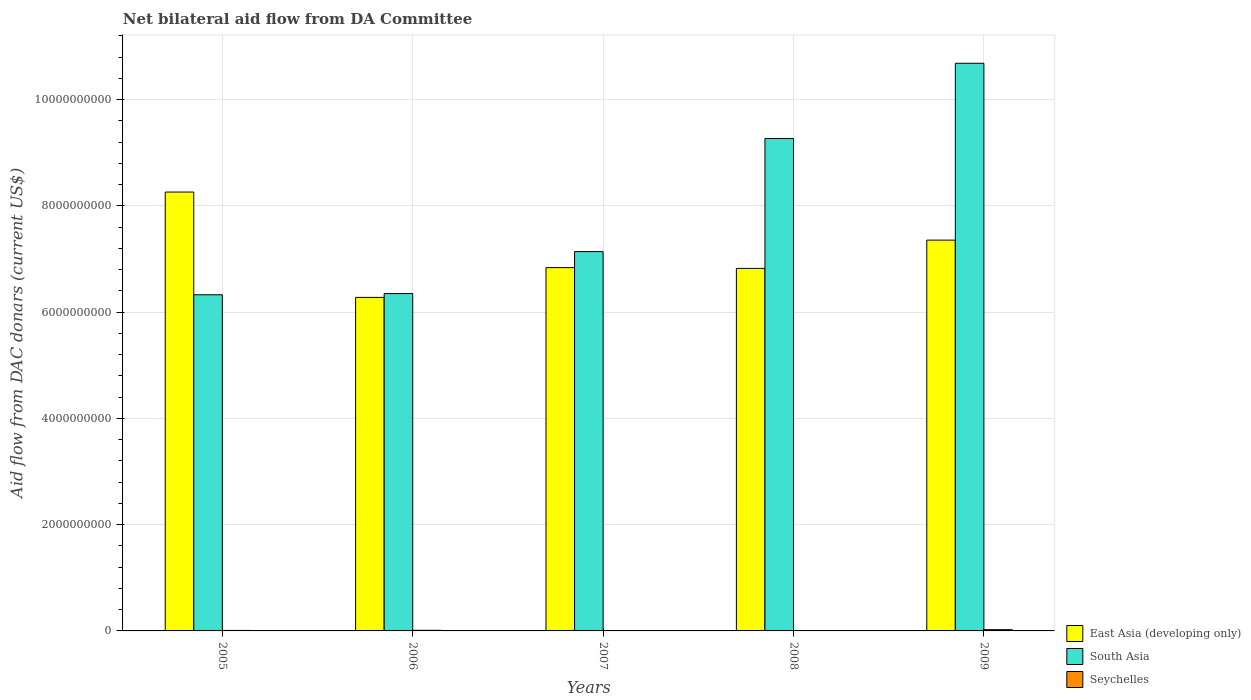How many bars are there on the 5th tick from the left?
Provide a succinct answer. 3. What is the aid flow in in South Asia in 2007?
Ensure brevity in your answer.  7.14e+09. Across all years, what is the maximum aid flow in in South Asia?
Ensure brevity in your answer.  1.07e+1. Across all years, what is the minimum aid flow in in Seychelles?
Your answer should be very brief. 2.29e+06. In which year was the aid flow in in Seychelles maximum?
Offer a very short reply. 2009. In which year was the aid flow in in Seychelles minimum?
Offer a very short reply. 2007. What is the total aid flow in in Seychelles in the graph?
Ensure brevity in your answer.  5.27e+07. What is the difference between the aid flow in in South Asia in 2006 and that in 2008?
Give a very brief answer. -2.92e+09. What is the difference between the aid flow in in Seychelles in 2008 and the aid flow in in South Asia in 2006?
Make the answer very short. -6.34e+09. What is the average aid flow in in South Asia per year?
Offer a very short reply. 7.95e+09. In the year 2009, what is the difference between the aid flow in in South Asia and aid flow in in East Asia (developing only)?
Provide a short and direct response. 3.33e+09. What is the ratio of the aid flow in in East Asia (developing only) in 2008 to that in 2009?
Offer a very short reply. 0.93. Is the aid flow in in East Asia (developing only) in 2008 less than that in 2009?
Your answer should be compact. Yes. Is the difference between the aid flow in in South Asia in 2005 and 2007 greater than the difference between the aid flow in in East Asia (developing only) in 2005 and 2007?
Your answer should be compact. No. What is the difference between the highest and the second highest aid flow in in South Asia?
Offer a terse response. 1.42e+09. What is the difference between the highest and the lowest aid flow in in East Asia (developing only)?
Ensure brevity in your answer.  1.98e+09. In how many years, is the aid flow in in East Asia (developing only) greater than the average aid flow in in East Asia (developing only) taken over all years?
Your answer should be very brief. 2. What does the 1st bar from the left in 2005 represents?
Keep it short and to the point. East Asia (developing only). What does the 3rd bar from the right in 2008 represents?
Ensure brevity in your answer.  East Asia (developing only). Is it the case that in every year, the sum of the aid flow in in South Asia and aid flow in in East Asia (developing only) is greater than the aid flow in in Seychelles?
Your answer should be compact. Yes. Are all the bars in the graph horizontal?
Your response must be concise. No. Are the values on the major ticks of Y-axis written in scientific E-notation?
Offer a very short reply. No. How are the legend labels stacked?
Your answer should be compact. Vertical. What is the title of the graph?
Your response must be concise. Net bilateral aid flow from DA Committee. Does "Sudan" appear as one of the legend labels in the graph?
Make the answer very short. No. What is the label or title of the Y-axis?
Your answer should be compact. Aid flow from DAC donars (current US$). What is the Aid flow from DAC donars (current US$) of East Asia (developing only) in 2005?
Give a very brief answer. 8.26e+09. What is the Aid flow from DAC donars (current US$) in South Asia in 2005?
Provide a short and direct response. 6.33e+09. What is the Aid flow from DAC donars (current US$) in Seychelles in 2005?
Provide a short and direct response. 9.34e+06. What is the Aid flow from DAC donars (current US$) in East Asia (developing only) in 2006?
Your answer should be very brief. 6.28e+09. What is the Aid flow from DAC donars (current US$) of South Asia in 2006?
Provide a short and direct response. 6.35e+09. What is the Aid flow from DAC donars (current US$) of Seychelles in 2006?
Offer a very short reply. 1.16e+07. What is the Aid flow from DAC donars (current US$) in East Asia (developing only) in 2007?
Offer a terse response. 6.84e+09. What is the Aid flow from DAC donars (current US$) of South Asia in 2007?
Provide a succinct answer. 7.14e+09. What is the Aid flow from DAC donars (current US$) in Seychelles in 2007?
Your response must be concise. 2.29e+06. What is the Aid flow from DAC donars (current US$) in East Asia (developing only) in 2008?
Give a very brief answer. 6.82e+09. What is the Aid flow from DAC donars (current US$) in South Asia in 2008?
Your answer should be very brief. 9.27e+09. What is the Aid flow from DAC donars (current US$) of Seychelles in 2008?
Your answer should be very brief. 5.77e+06. What is the Aid flow from DAC donars (current US$) in East Asia (developing only) in 2009?
Your answer should be very brief. 7.35e+09. What is the Aid flow from DAC donars (current US$) of South Asia in 2009?
Provide a succinct answer. 1.07e+1. What is the Aid flow from DAC donars (current US$) of Seychelles in 2009?
Provide a succinct answer. 2.38e+07. Across all years, what is the maximum Aid flow from DAC donars (current US$) of East Asia (developing only)?
Offer a terse response. 8.26e+09. Across all years, what is the maximum Aid flow from DAC donars (current US$) in South Asia?
Provide a short and direct response. 1.07e+1. Across all years, what is the maximum Aid flow from DAC donars (current US$) in Seychelles?
Provide a succinct answer. 2.38e+07. Across all years, what is the minimum Aid flow from DAC donars (current US$) in East Asia (developing only)?
Ensure brevity in your answer.  6.28e+09. Across all years, what is the minimum Aid flow from DAC donars (current US$) in South Asia?
Your answer should be compact. 6.33e+09. Across all years, what is the minimum Aid flow from DAC donars (current US$) of Seychelles?
Your answer should be very brief. 2.29e+06. What is the total Aid flow from DAC donars (current US$) of East Asia (developing only) in the graph?
Provide a short and direct response. 3.55e+1. What is the total Aid flow from DAC donars (current US$) in South Asia in the graph?
Make the answer very short. 3.98e+1. What is the total Aid flow from DAC donars (current US$) of Seychelles in the graph?
Ensure brevity in your answer.  5.27e+07. What is the difference between the Aid flow from DAC donars (current US$) in East Asia (developing only) in 2005 and that in 2006?
Your response must be concise. 1.98e+09. What is the difference between the Aid flow from DAC donars (current US$) in South Asia in 2005 and that in 2006?
Make the answer very short. -2.28e+07. What is the difference between the Aid flow from DAC donars (current US$) in Seychelles in 2005 and that in 2006?
Provide a short and direct response. -2.21e+06. What is the difference between the Aid flow from DAC donars (current US$) in East Asia (developing only) in 2005 and that in 2007?
Your answer should be compact. 1.42e+09. What is the difference between the Aid flow from DAC donars (current US$) in South Asia in 2005 and that in 2007?
Your answer should be very brief. -8.12e+08. What is the difference between the Aid flow from DAC donars (current US$) of Seychelles in 2005 and that in 2007?
Keep it short and to the point. 7.05e+06. What is the difference between the Aid flow from DAC donars (current US$) in East Asia (developing only) in 2005 and that in 2008?
Make the answer very short. 1.44e+09. What is the difference between the Aid flow from DAC donars (current US$) in South Asia in 2005 and that in 2008?
Make the answer very short. -2.94e+09. What is the difference between the Aid flow from DAC donars (current US$) of Seychelles in 2005 and that in 2008?
Ensure brevity in your answer.  3.57e+06. What is the difference between the Aid flow from DAC donars (current US$) in East Asia (developing only) in 2005 and that in 2009?
Provide a succinct answer. 9.04e+08. What is the difference between the Aid flow from DAC donars (current US$) in South Asia in 2005 and that in 2009?
Keep it short and to the point. -4.36e+09. What is the difference between the Aid flow from DAC donars (current US$) in Seychelles in 2005 and that in 2009?
Keep it short and to the point. -1.44e+07. What is the difference between the Aid flow from DAC donars (current US$) in East Asia (developing only) in 2006 and that in 2007?
Your answer should be compact. -5.60e+08. What is the difference between the Aid flow from DAC donars (current US$) of South Asia in 2006 and that in 2007?
Offer a very short reply. -7.90e+08. What is the difference between the Aid flow from DAC donars (current US$) of Seychelles in 2006 and that in 2007?
Your response must be concise. 9.26e+06. What is the difference between the Aid flow from DAC donars (current US$) of East Asia (developing only) in 2006 and that in 2008?
Ensure brevity in your answer.  -5.46e+08. What is the difference between the Aid flow from DAC donars (current US$) in South Asia in 2006 and that in 2008?
Provide a succinct answer. -2.92e+09. What is the difference between the Aid flow from DAC donars (current US$) in Seychelles in 2006 and that in 2008?
Make the answer very short. 5.78e+06. What is the difference between the Aid flow from DAC donars (current US$) of East Asia (developing only) in 2006 and that in 2009?
Ensure brevity in your answer.  -1.08e+09. What is the difference between the Aid flow from DAC donars (current US$) in South Asia in 2006 and that in 2009?
Give a very brief answer. -4.33e+09. What is the difference between the Aid flow from DAC donars (current US$) of Seychelles in 2006 and that in 2009?
Ensure brevity in your answer.  -1.22e+07. What is the difference between the Aid flow from DAC donars (current US$) in East Asia (developing only) in 2007 and that in 2008?
Give a very brief answer. 1.45e+07. What is the difference between the Aid flow from DAC donars (current US$) in South Asia in 2007 and that in 2008?
Your answer should be compact. -2.13e+09. What is the difference between the Aid flow from DAC donars (current US$) in Seychelles in 2007 and that in 2008?
Offer a terse response. -3.48e+06. What is the difference between the Aid flow from DAC donars (current US$) of East Asia (developing only) in 2007 and that in 2009?
Make the answer very short. -5.18e+08. What is the difference between the Aid flow from DAC donars (current US$) of South Asia in 2007 and that in 2009?
Provide a succinct answer. -3.54e+09. What is the difference between the Aid flow from DAC donars (current US$) in Seychelles in 2007 and that in 2009?
Your answer should be very brief. -2.15e+07. What is the difference between the Aid flow from DAC donars (current US$) of East Asia (developing only) in 2008 and that in 2009?
Make the answer very short. -5.32e+08. What is the difference between the Aid flow from DAC donars (current US$) in South Asia in 2008 and that in 2009?
Offer a very short reply. -1.42e+09. What is the difference between the Aid flow from DAC donars (current US$) of Seychelles in 2008 and that in 2009?
Ensure brevity in your answer.  -1.80e+07. What is the difference between the Aid flow from DAC donars (current US$) in East Asia (developing only) in 2005 and the Aid flow from DAC donars (current US$) in South Asia in 2006?
Make the answer very short. 1.91e+09. What is the difference between the Aid flow from DAC donars (current US$) of East Asia (developing only) in 2005 and the Aid flow from DAC donars (current US$) of Seychelles in 2006?
Keep it short and to the point. 8.25e+09. What is the difference between the Aid flow from DAC donars (current US$) of South Asia in 2005 and the Aid flow from DAC donars (current US$) of Seychelles in 2006?
Your answer should be very brief. 6.31e+09. What is the difference between the Aid flow from DAC donars (current US$) in East Asia (developing only) in 2005 and the Aid flow from DAC donars (current US$) in South Asia in 2007?
Offer a terse response. 1.12e+09. What is the difference between the Aid flow from DAC donars (current US$) of East Asia (developing only) in 2005 and the Aid flow from DAC donars (current US$) of Seychelles in 2007?
Offer a very short reply. 8.26e+09. What is the difference between the Aid flow from DAC donars (current US$) of South Asia in 2005 and the Aid flow from DAC donars (current US$) of Seychelles in 2007?
Your answer should be compact. 6.32e+09. What is the difference between the Aid flow from DAC donars (current US$) in East Asia (developing only) in 2005 and the Aid flow from DAC donars (current US$) in South Asia in 2008?
Offer a very short reply. -1.01e+09. What is the difference between the Aid flow from DAC donars (current US$) in East Asia (developing only) in 2005 and the Aid flow from DAC donars (current US$) in Seychelles in 2008?
Provide a short and direct response. 8.25e+09. What is the difference between the Aid flow from DAC donars (current US$) in South Asia in 2005 and the Aid flow from DAC donars (current US$) in Seychelles in 2008?
Provide a short and direct response. 6.32e+09. What is the difference between the Aid flow from DAC donars (current US$) in East Asia (developing only) in 2005 and the Aid flow from DAC donars (current US$) in South Asia in 2009?
Your response must be concise. -2.42e+09. What is the difference between the Aid flow from DAC donars (current US$) of East Asia (developing only) in 2005 and the Aid flow from DAC donars (current US$) of Seychelles in 2009?
Provide a succinct answer. 8.24e+09. What is the difference between the Aid flow from DAC donars (current US$) in South Asia in 2005 and the Aid flow from DAC donars (current US$) in Seychelles in 2009?
Your answer should be compact. 6.30e+09. What is the difference between the Aid flow from DAC donars (current US$) in East Asia (developing only) in 2006 and the Aid flow from DAC donars (current US$) in South Asia in 2007?
Your answer should be very brief. -8.62e+08. What is the difference between the Aid flow from DAC donars (current US$) in East Asia (developing only) in 2006 and the Aid flow from DAC donars (current US$) in Seychelles in 2007?
Your answer should be very brief. 6.27e+09. What is the difference between the Aid flow from DAC donars (current US$) in South Asia in 2006 and the Aid flow from DAC donars (current US$) in Seychelles in 2007?
Your response must be concise. 6.35e+09. What is the difference between the Aid flow from DAC donars (current US$) of East Asia (developing only) in 2006 and the Aid flow from DAC donars (current US$) of South Asia in 2008?
Provide a succinct answer. -2.99e+09. What is the difference between the Aid flow from DAC donars (current US$) of East Asia (developing only) in 2006 and the Aid flow from DAC donars (current US$) of Seychelles in 2008?
Your answer should be compact. 6.27e+09. What is the difference between the Aid flow from DAC donars (current US$) in South Asia in 2006 and the Aid flow from DAC donars (current US$) in Seychelles in 2008?
Provide a succinct answer. 6.34e+09. What is the difference between the Aid flow from DAC donars (current US$) of East Asia (developing only) in 2006 and the Aid flow from DAC donars (current US$) of South Asia in 2009?
Keep it short and to the point. -4.41e+09. What is the difference between the Aid flow from DAC donars (current US$) of East Asia (developing only) in 2006 and the Aid flow from DAC donars (current US$) of Seychelles in 2009?
Offer a terse response. 6.25e+09. What is the difference between the Aid flow from DAC donars (current US$) in South Asia in 2006 and the Aid flow from DAC donars (current US$) in Seychelles in 2009?
Your answer should be compact. 6.33e+09. What is the difference between the Aid flow from DAC donars (current US$) of East Asia (developing only) in 2007 and the Aid flow from DAC donars (current US$) of South Asia in 2008?
Keep it short and to the point. -2.43e+09. What is the difference between the Aid flow from DAC donars (current US$) of East Asia (developing only) in 2007 and the Aid flow from DAC donars (current US$) of Seychelles in 2008?
Provide a short and direct response. 6.83e+09. What is the difference between the Aid flow from DAC donars (current US$) of South Asia in 2007 and the Aid flow from DAC donars (current US$) of Seychelles in 2008?
Offer a terse response. 7.13e+09. What is the difference between the Aid flow from DAC donars (current US$) in East Asia (developing only) in 2007 and the Aid flow from DAC donars (current US$) in South Asia in 2009?
Keep it short and to the point. -3.85e+09. What is the difference between the Aid flow from DAC donars (current US$) of East Asia (developing only) in 2007 and the Aid flow from DAC donars (current US$) of Seychelles in 2009?
Provide a short and direct response. 6.81e+09. What is the difference between the Aid flow from DAC donars (current US$) in South Asia in 2007 and the Aid flow from DAC donars (current US$) in Seychelles in 2009?
Provide a short and direct response. 7.11e+09. What is the difference between the Aid flow from DAC donars (current US$) in East Asia (developing only) in 2008 and the Aid flow from DAC donars (current US$) in South Asia in 2009?
Your response must be concise. -3.86e+09. What is the difference between the Aid flow from DAC donars (current US$) of East Asia (developing only) in 2008 and the Aid flow from DAC donars (current US$) of Seychelles in 2009?
Make the answer very short. 6.80e+09. What is the difference between the Aid flow from DAC donars (current US$) of South Asia in 2008 and the Aid flow from DAC donars (current US$) of Seychelles in 2009?
Make the answer very short. 9.24e+09. What is the average Aid flow from DAC donars (current US$) in East Asia (developing only) per year?
Make the answer very short. 7.11e+09. What is the average Aid flow from DAC donars (current US$) of South Asia per year?
Your response must be concise. 7.95e+09. What is the average Aid flow from DAC donars (current US$) of Seychelles per year?
Offer a very short reply. 1.05e+07. In the year 2005, what is the difference between the Aid flow from DAC donars (current US$) in East Asia (developing only) and Aid flow from DAC donars (current US$) in South Asia?
Provide a short and direct response. 1.93e+09. In the year 2005, what is the difference between the Aid flow from DAC donars (current US$) in East Asia (developing only) and Aid flow from DAC donars (current US$) in Seychelles?
Make the answer very short. 8.25e+09. In the year 2005, what is the difference between the Aid flow from DAC donars (current US$) of South Asia and Aid flow from DAC donars (current US$) of Seychelles?
Make the answer very short. 6.32e+09. In the year 2006, what is the difference between the Aid flow from DAC donars (current US$) of East Asia (developing only) and Aid flow from DAC donars (current US$) of South Asia?
Offer a very short reply. -7.22e+07. In the year 2006, what is the difference between the Aid flow from DAC donars (current US$) in East Asia (developing only) and Aid flow from DAC donars (current US$) in Seychelles?
Provide a succinct answer. 6.27e+09. In the year 2006, what is the difference between the Aid flow from DAC donars (current US$) in South Asia and Aid flow from DAC donars (current US$) in Seychelles?
Your answer should be very brief. 6.34e+09. In the year 2007, what is the difference between the Aid flow from DAC donars (current US$) of East Asia (developing only) and Aid flow from DAC donars (current US$) of South Asia?
Ensure brevity in your answer.  -3.01e+08. In the year 2007, what is the difference between the Aid flow from DAC donars (current US$) in East Asia (developing only) and Aid flow from DAC donars (current US$) in Seychelles?
Keep it short and to the point. 6.83e+09. In the year 2007, what is the difference between the Aid flow from DAC donars (current US$) in South Asia and Aid flow from DAC donars (current US$) in Seychelles?
Your response must be concise. 7.14e+09. In the year 2008, what is the difference between the Aid flow from DAC donars (current US$) of East Asia (developing only) and Aid flow from DAC donars (current US$) of South Asia?
Give a very brief answer. -2.44e+09. In the year 2008, what is the difference between the Aid flow from DAC donars (current US$) of East Asia (developing only) and Aid flow from DAC donars (current US$) of Seychelles?
Your answer should be very brief. 6.82e+09. In the year 2008, what is the difference between the Aid flow from DAC donars (current US$) in South Asia and Aid flow from DAC donars (current US$) in Seychelles?
Give a very brief answer. 9.26e+09. In the year 2009, what is the difference between the Aid flow from DAC donars (current US$) of East Asia (developing only) and Aid flow from DAC donars (current US$) of South Asia?
Your answer should be very brief. -3.33e+09. In the year 2009, what is the difference between the Aid flow from DAC donars (current US$) of East Asia (developing only) and Aid flow from DAC donars (current US$) of Seychelles?
Your answer should be very brief. 7.33e+09. In the year 2009, what is the difference between the Aid flow from DAC donars (current US$) in South Asia and Aid flow from DAC donars (current US$) in Seychelles?
Your response must be concise. 1.07e+1. What is the ratio of the Aid flow from DAC donars (current US$) of East Asia (developing only) in 2005 to that in 2006?
Offer a very short reply. 1.32. What is the ratio of the Aid flow from DAC donars (current US$) in South Asia in 2005 to that in 2006?
Provide a succinct answer. 1. What is the ratio of the Aid flow from DAC donars (current US$) in Seychelles in 2005 to that in 2006?
Your answer should be very brief. 0.81. What is the ratio of the Aid flow from DAC donars (current US$) in East Asia (developing only) in 2005 to that in 2007?
Provide a succinct answer. 1.21. What is the ratio of the Aid flow from DAC donars (current US$) of South Asia in 2005 to that in 2007?
Your response must be concise. 0.89. What is the ratio of the Aid flow from DAC donars (current US$) of Seychelles in 2005 to that in 2007?
Your answer should be compact. 4.08. What is the ratio of the Aid flow from DAC donars (current US$) of East Asia (developing only) in 2005 to that in 2008?
Ensure brevity in your answer.  1.21. What is the ratio of the Aid flow from DAC donars (current US$) of South Asia in 2005 to that in 2008?
Provide a short and direct response. 0.68. What is the ratio of the Aid flow from DAC donars (current US$) in Seychelles in 2005 to that in 2008?
Give a very brief answer. 1.62. What is the ratio of the Aid flow from DAC donars (current US$) in East Asia (developing only) in 2005 to that in 2009?
Provide a succinct answer. 1.12. What is the ratio of the Aid flow from DAC donars (current US$) of South Asia in 2005 to that in 2009?
Ensure brevity in your answer.  0.59. What is the ratio of the Aid flow from DAC donars (current US$) of Seychelles in 2005 to that in 2009?
Make the answer very short. 0.39. What is the ratio of the Aid flow from DAC donars (current US$) in East Asia (developing only) in 2006 to that in 2007?
Your response must be concise. 0.92. What is the ratio of the Aid flow from DAC donars (current US$) in South Asia in 2006 to that in 2007?
Make the answer very short. 0.89. What is the ratio of the Aid flow from DAC donars (current US$) in Seychelles in 2006 to that in 2007?
Ensure brevity in your answer.  5.04. What is the ratio of the Aid flow from DAC donars (current US$) in South Asia in 2006 to that in 2008?
Offer a terse response. 0.69. What is the ratio of the Aid flow from DAC donars (current US$) in Seychelles in 2006 to that in 2008?
Keep it short and to the point. 2. What is the ratio of the Aid flow from DAC donars (current US$) of East Asia (developing only) in 2006 to that in 2009?
Your response must be concise. 0.85. What is the ratio of the Aid flow from DAC donars (current US$) of South Asia in 2006 to that in 2009?
Offer a very short reply. 0.59. What is the ratio of the Aid flow from DAC donars (current US$) in Seychelles in 2006 to that in 2009?
Your answer should be compact. 0.49. What is the ratio of the Aid flow from DAC donars (current US$) in South Asia in 2007 to that in 2008?
Your response must be concise. 0.77. What is the ratio of the Aid flow from DAC donars (current US$) of Seychelles in 2007 to that in 2008?
Your answer should be compact. 0.4. What is the ratio of the Aid flow from DAC donars (current US$) in East Asia (developing only) in 2007 to that in 2009?
Ensure brevity in your answer.  0.93. What is the ratio of the Aid flow from DAC donars (current US$) in South Asia in 2007 to that in 2009?
Provide a short and direct response. 0.67. What is the ratio of the Aid flow from DAC donars (current US$) in Seychelles in 2007 to that in 2009?
Ensure brevity in your answer.  0.1. What is the ratio of the Aid flow from DAC donars (current US$) of East Asia (developing only) in 2008 to that in 2009?
Your answer should be very brief. 0.93. What is the ratio of the Aid flow from DAC donars (current US$) of South Asia in 2008 to that in 2009?
Your answer should be very brief. 0.87. What is the ratio of the Aid flow from DAC donars (current US$) in Seychelles in 2008 to that in 2009?
Keep it short and to the point. 0.24. What is the difference between the highest and the second highest Aid flow from DAC donars (current US$) in East Asia (developing only)?
Ensure brevity in your answer.  9.04e+08. What is the difference between the highest and the second highest Aid flow from DAC donars (current US$) in South Asia?
Your answer should be very brief. 1.42e+09. What is the difference between the highest and the second highest Aid flow from DAC donars (current US$) in Seychelles?
Your answer should be compact. 1.22e+07. What is the difference between the highest and the lowest Aid flow from DAC donars (current US$) of East Asia (developing only)?
Your answer should be very brief. 1.98e+09. What is the difference between the highest and the lowest Aid flow from DAC donars (current US$) in South Asia?
Your response must be concise. 4.36e+09. What is the difference between the highest and the lowest Aid flow from DAC donars (current US$) of Seychelles?
Your response must be concise. 2.15e+07. 